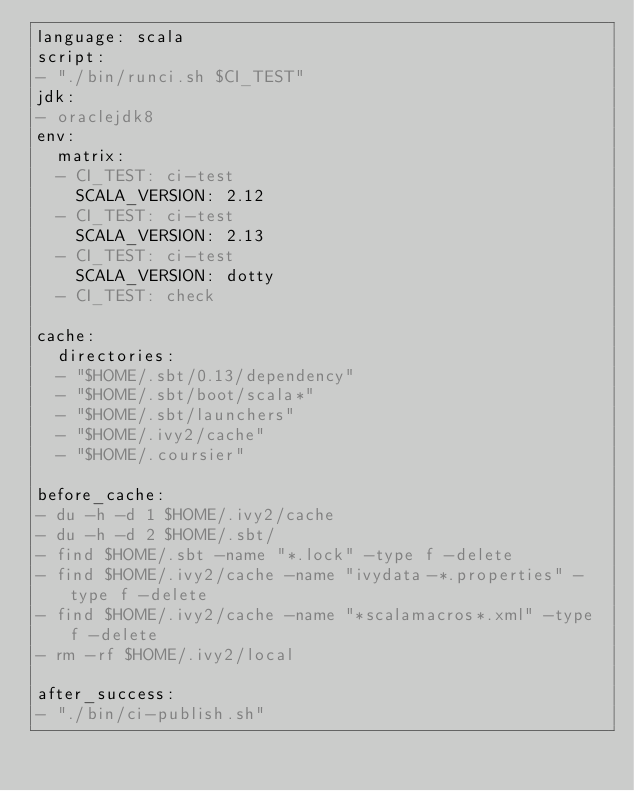<code> <loc_0><loc_0><loc_500><loc_500><_YAML_>language: scala
script:
- "./bin/runci.sh $CI_TEST"
jdk:
- oraclejdk8
env:
  matrix:
  - CI_TEST: ci-test
    SCALA_VERSION: 2.12
  - CI_TEST: ci-test
    SCALA_VERSION: 2.13
  - CI_TEST: ci-test
    SCALA_VERSION: dotty
  - CI_TEST: check

cache:
  directories:
  - "$HOME/.sbt/0.13/dependency"
  - "$HOME/.sbt/boot/scala*"
  - "$HOME/.sbt/launchers"
  - "$HOME/.ivy2/cache"
  - "$HOME/.coursier"

before_cache:
- du -h -d 1 $HOME/.ivy2/cache
- du -h -d 2 $HOME/.sbt/
- find $HOME/.sbt -name "*.lock" -type f -delete
- find $HOME/.ivy2/cache -name "ivydata-*.properties" -type f -delete
- find $HOME/.ivy2/cache -name "*scalamacros*.xml" -type f -delete
- rm -rf $HOME/.ivy2/local

after_success:
- "./bin/ci-publish.sh"
</code> 